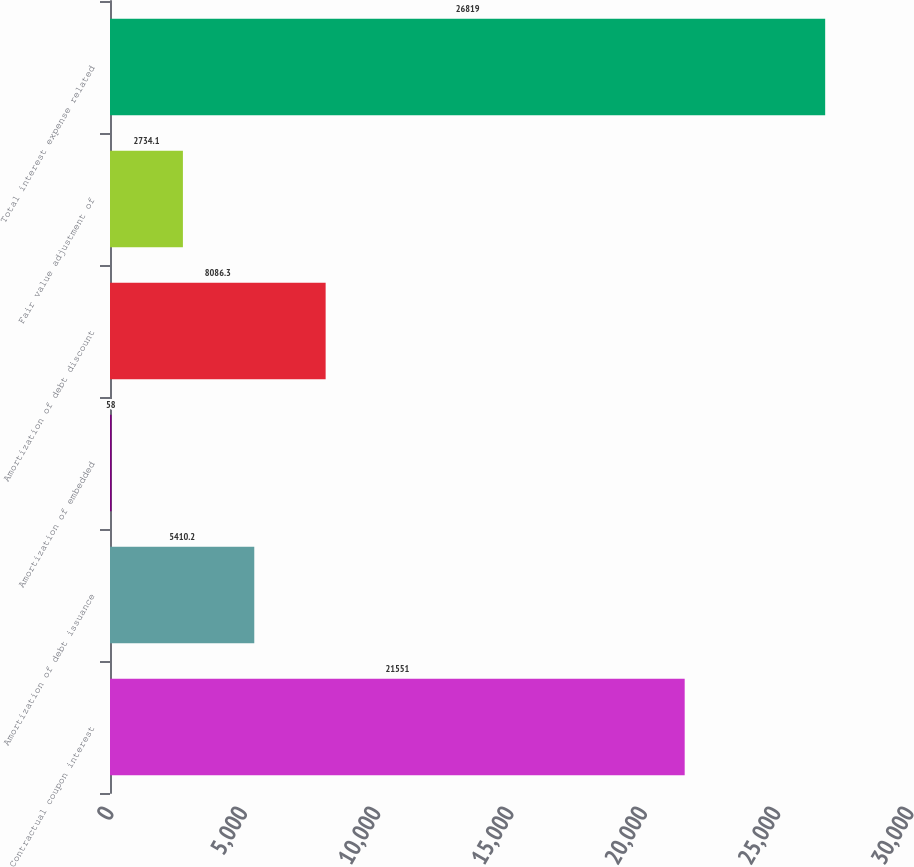Convert chart. <chart><loc_0><loc_0><loc_500><loc_500><bar_chart><fcel>Contractual coupon interest<fcel>Amortization of debt issuance<fcel>Amortization of embedded<fcel>Amortization of debt discount<fcel>Fair value adjustment of<fcel>Total interest expense related<nl><fcel>21551<fcel>5410.2<fcel>58<fcel>8086.3<fcel>2734.1<fcel>26819<nl></chart> 